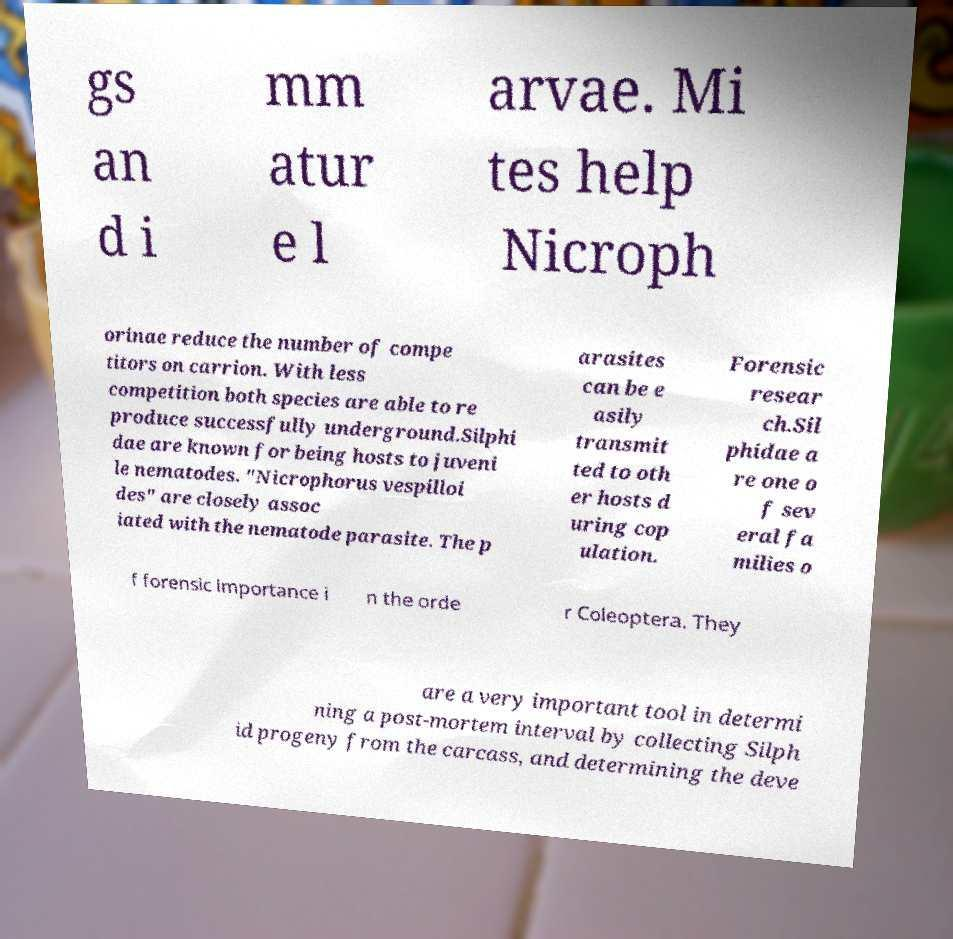Please read and relay the text visible in this image. What does it say? gs an d i mm atur e l arvae. Mi tes help Nicroph orinae reduce the number of compe titors on carrion. With less competition both species are able to re produce successfully underground.Silphi dae are known for being hosts to juveni le nematodes. "Nicrophorus vespilloi des" are closely assoc iated with the nematode parasite. The p arasites can be e asily transmit ted to oth er hosts d uring cop ulation. Forensic resear ch.Sil phidae a re one o f sev eral fa milies o f forensic importance i n the orde r Coleoptera. They are a very important tool in determi ning a post-mortem interval by collecting Silph id progeny from the carcass, and determining the deve 